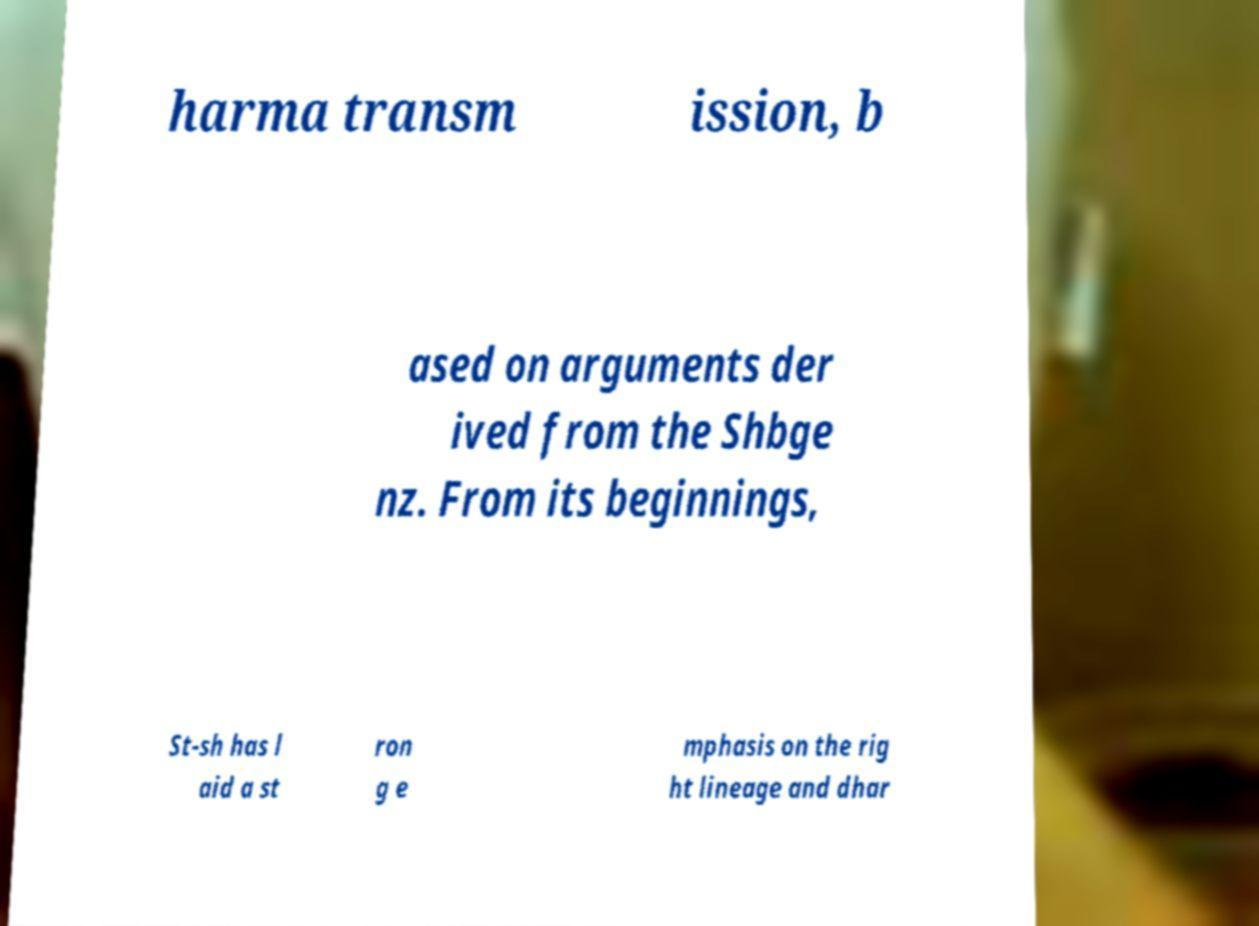What messages or text are displayed in this image? I need them in a readable, typed format. harma transm ission, b ased on arguments der ived from the Shbge nz. From its beginnings, St-sh has l aid a st ron g e mphasis on the rig ht lineage and dhar 